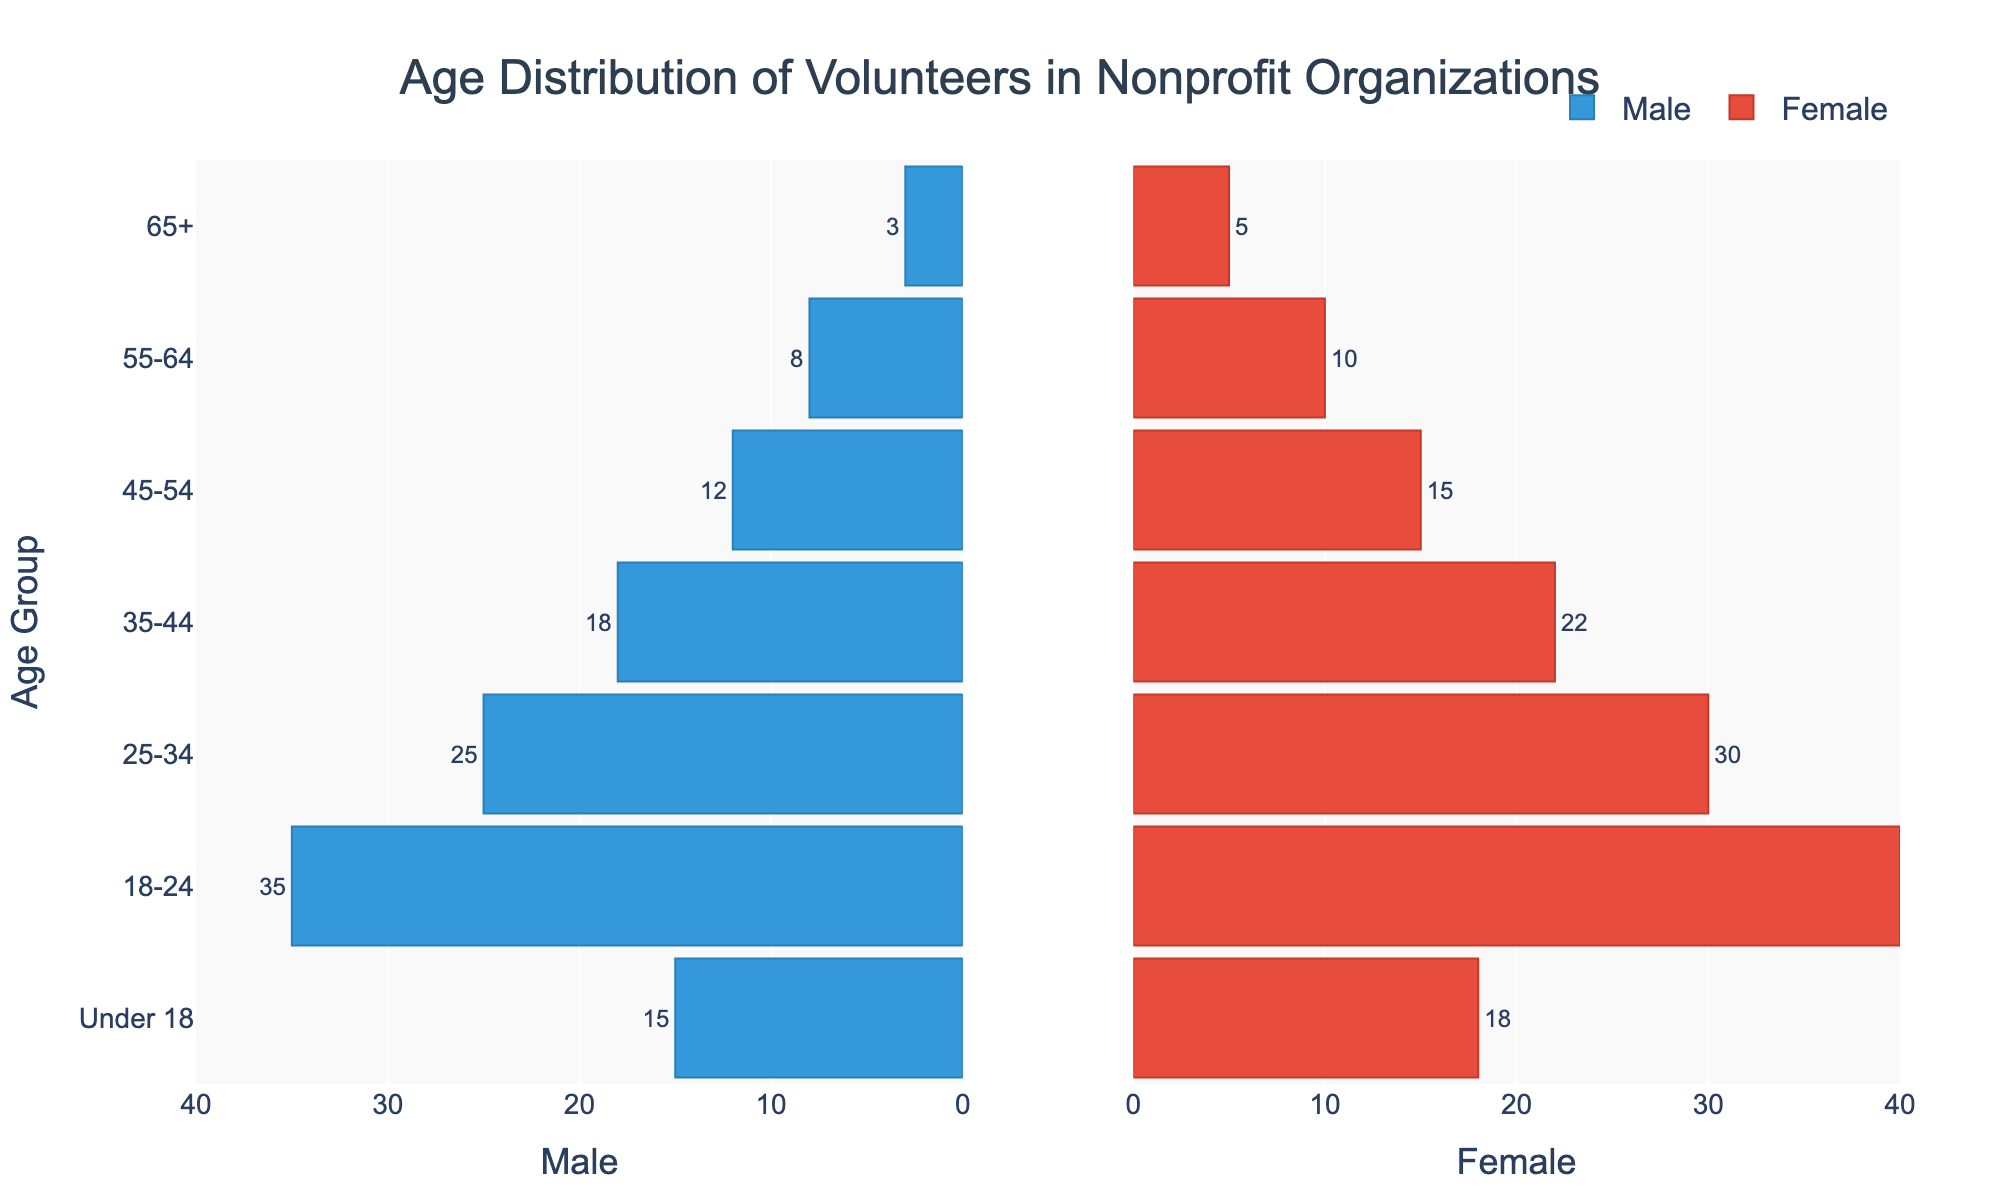What's the title of the plot? The title of the plot is written at the top center of the figure.
Answer: Age Distribution of Volunteers in Nonprofit Organizations How many male volunteers are there in the 25-34 age group? You can find the number of male volunteers by looking at the length of the bar for the 25-34 age group on the left side. The label on the bar shows the value.
Answer: 25 Which age group has the highest number of female volunteers? To find the age group with the highest number of female volunteers, look for the longest bar on the right side of the pyramid.
Answer: 18-24 What is the total number of volunteers (male and female) in the 45-54 age group? Add the number of male volunteers in the 45-54 age group to the number of female volunteers in the same group. According to the bar lengths, we have 12 males and 15 females.
Answer: 27 How many volunteers are there in the 'Under 18' age group? Add the male and female volunteers in the 'Under 18' age group. From the pyramid, we have 15 males and 18 females.
Answer: 33 Are there more male or female volunteers in the 35-44 age group? Compare the lengths of the bars for males and females in the 35-44 age group. The right bar represents females and the left bar represents males.
Answer: Female Which age group has the smallest number of male volunteers? To determine this, look for the shortest bar on the left side of the pyramid.
Answer: 65+ What is the difference between the number of female volunteers in the 18-24 age group and the number of female volunteers in the 65+ age group? Subtract the number of female volunteers in the 65+ age group (5) from the number of female volunteers in the 18-24 age group (40).
Answer: 35 What percentage of the total volunteers are in the 18-24 age group? First, calculate the total number of volunteers across all age groups by summing up all the male and female counts. The total number of volunteers = 3+8+12+18+25+35+15 (males) + 5+10+15+22+30+40+18 (females) = 263. Next, sum the male and female volunteers in the 18-24 age group, which equals 35 + 40 = 75. Finally, calculate the percentage: (75 / 263) * 100.
Answer: 28.52% In the 55-64 age group, is the number of male volunteers greater than the number of female volunteers? To find this, compare the bars for males and females in the 55-64 age group. The left bar (males) is 8, and the right bar (females) is 10.
Answer: No 